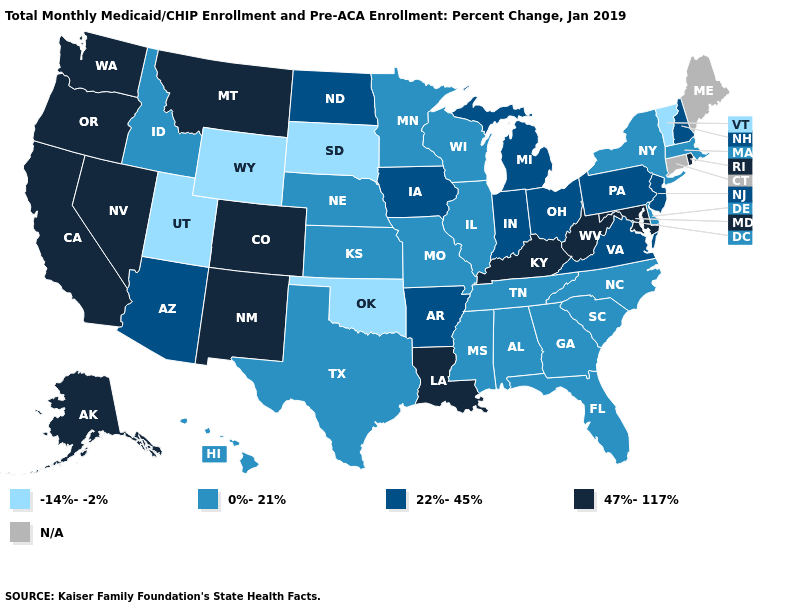Does the map have missing data?
Quick response, please. Yes. Does the map have missing data?
Answer briefly. Yes. Among the states that border Washington , does Idaho have the highest value?
Be succinct. No. Name the states that have a value in the range 0%-21%?
Quick response, please. Alabama, Delaware, Florida, Georgia, Hawaii, Idaho, Illinois, Kansas, Massachusetts, Minnesota, Mississippi, Missouri, Nebraska, New York, North Carolina, South Carolina, Tennessee, Texas, Wisconsin. Among the states that border Montana , which have the lowest value?
Quick response, please. South Dakota, Wyoming. What is the value of Utah?
Give a very brief answer. -14%--2%. What is the value of Utah?
Keep it brief. -14%--2%. What is the value of Pennsylvania?
Keep it brief. 22%-45%. What is the value of Montana?
Write a very short answer. 47%-117%. What is the lowest value in the USA?
Write a very short answer. -14%--2%. Name the states that have a value in the range 22%-45%?
Be succinct. Arizona, Arkansas, Indiana, Iowa, Michigan, New Hampshire, New Jersey, North Dakota, Ohio, Pennsylvania, Virginia. Does Mississippi have the lowest value in the USA?
Quick response, please. No. What is the lowest value in the Northeast?
Write a very short answer. -14%--2%. 